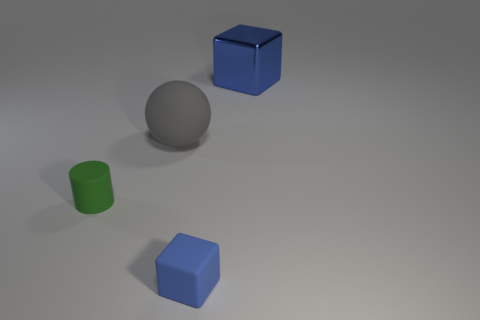What do the shapes and their arrangement suggest? The arrangement of shapes is reminiscent of a simple composition exercise, possibly used in a basic 3D modeling or rendering tutorial to demonstrate shapes, shading, and perspective. What can you tell me about the lighting in the image? The lighting appears to be diffused, coming from above, as indicated by the soft shadows projected directly underneath each object, suggesting an overcast sky or an evenly lit studio. 